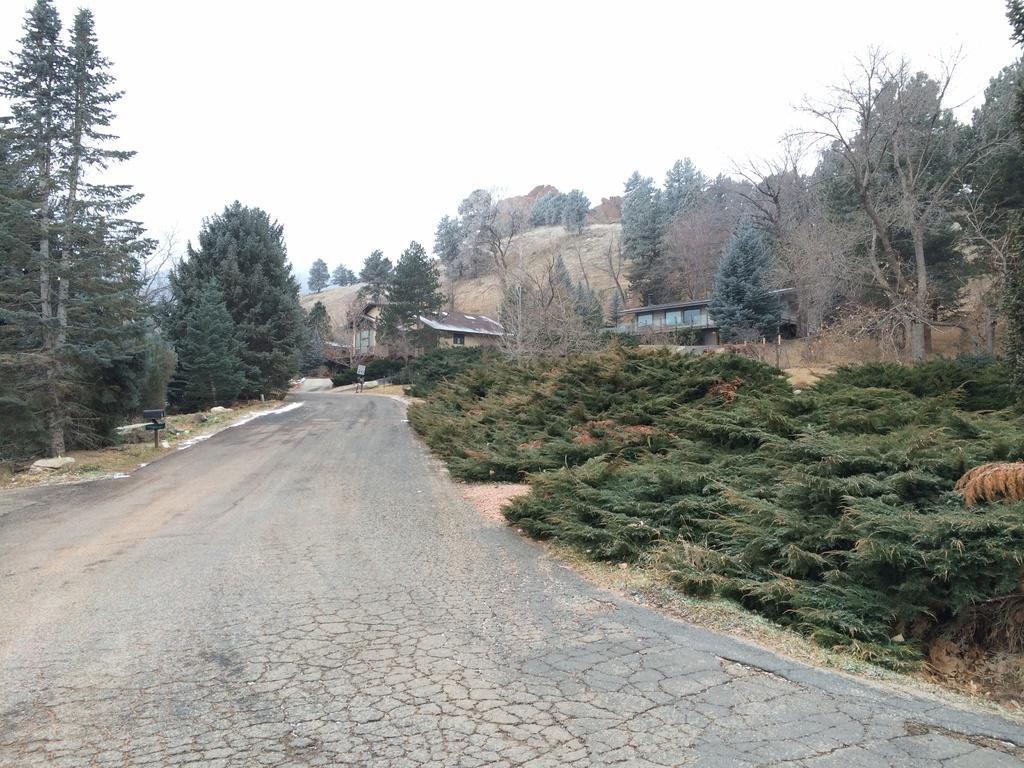In one or two sentences, can you explain what this image depicts? This picture is clicked outside. In the center we can see the ground. On the right there are some plants. In the background we can see the sky, hills, trees, houses and some objects. 